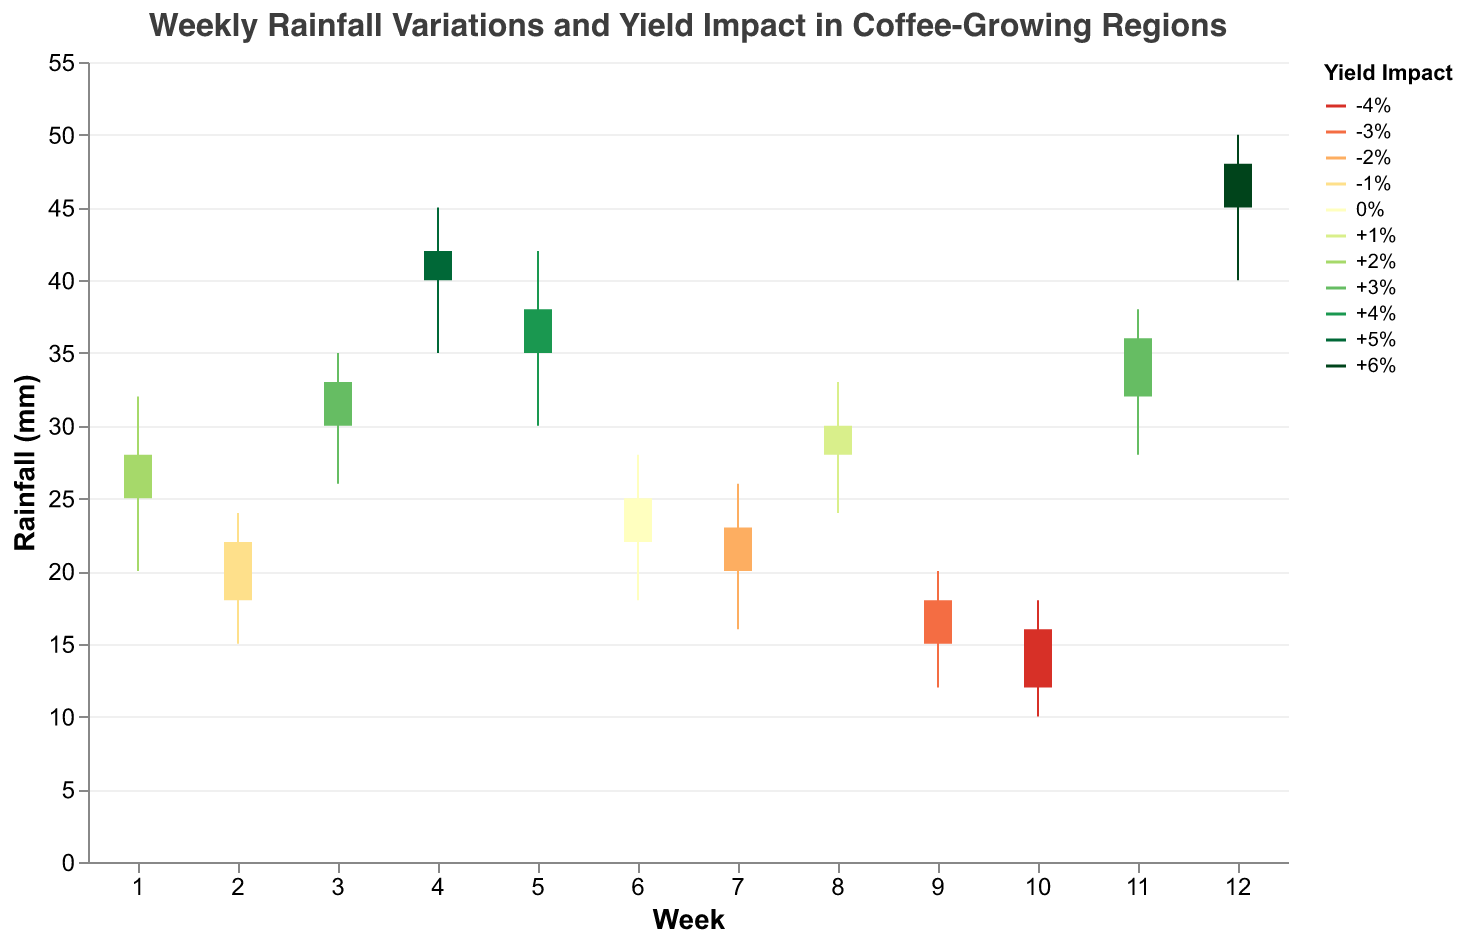What is the title of the chart? The chart title is typically displayed at the top of the figure. Here, it reads "Weekly Rainfall Variations and Yield Impact in Coffee-Growing Regions."
Answer: Weekly Rainfall Variations and Yield Impact in Coffee-Growing Regions What does the 'Close' value represent for Week 4 in Vietnam? To identify the 'Close' value, look for Week 4 on the x-axis and find the corresponding bar for Vietnam; the 'Close' value is labeled in the tooltip.
Answer: 42 Which region experienced the highest rainfall during any given week, and what was its value? To find the highest rainfall, look at the 'High' values on the y-axis. The highest 'High' value is 50 mm in Week 12 for India.
Answer: India, 50 mm How did the yield change in Brazil over the observed week? Look at the tooltip or color-coded bars for Week 2 corresponding to Brazil. The 'YieldImpact' value will answer the question.
Answer: -1% Which region had the lowest opening rainfall, and what was its value? To determine this, scan all 'Open' values for each week and find the lowest one, which is 12 mm in Week 10 for Mexico.
Answer: Mexico, 12 mm Compare the yield impacts between Vietnam and Indonesia. Which region had a higher impact and by how much? Find both regions by their tooltips or bars. Vietnam had +5% and Indonesia had +4%. Subtract Indonesia's impact from Vietnam's to find the difference.
Answer: Vietnam, +1% Calculate the average rainfall for Ethiopia during Week 3 (Open and Close values). Add Ethiopia's 'Open' (30) and 'Close' (33) values for Week 3, then divide by 2 for the average. (30 + 33) / 2 = 31.5
Answer: 31.5 mm Which week saw the largest range in rainfall for Guatemala? The largest range is found by subtracting 'Low' from 'High' values. For Guatemala in Week 7, it’s 26 - 16 = 10 mm.
Answer: Week 7, 10 mm What is the relationship between weekly rainfall and yield impact in Honduras? Check both the rainfall data (Open, High, Low, Close) and the 'YieldImpact' in Week 8 for Honduras. Rainfall doesn't change dramatically, and the 'YieldImpact' is +1%.
Answer: Minimal rainfall variation, +1% Yield Impact Identify two regions with a negative yield impact and compare their 'Close' rainfall values. Regions with a negative yield are Brazil and Guatemala. Compare their ‘Close’ values for Weeks 2 and 7 respectively. Brazil's 'Close' is 22, Guatemala's 'Close' is 23.
Answer: Brazil: 22, Guatemala: 23 